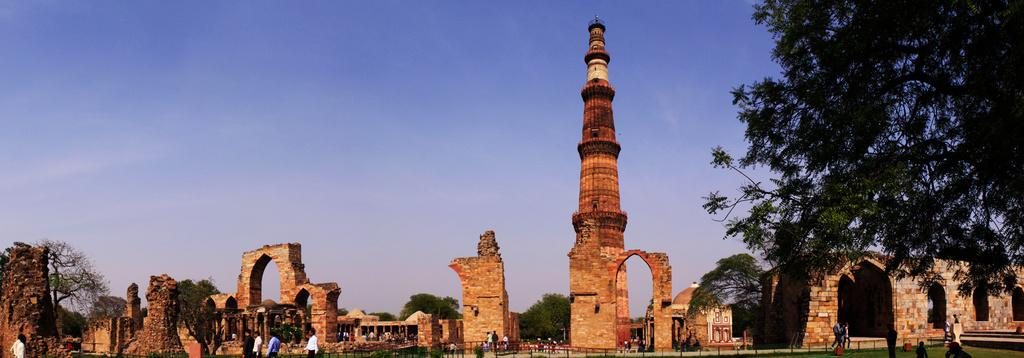What is the main structure in the image? There is a tower in the image. What else can be seen in the image besides the tower? There are walls, trees, and people walking in the image. Can you describe the natural elements in the image? There are trees in the image. What is visible in the background of the image? The sky is visible in the background of the image. What type of treatment is the boy receiving from the band in the image? There is no boy or band present in the image. 